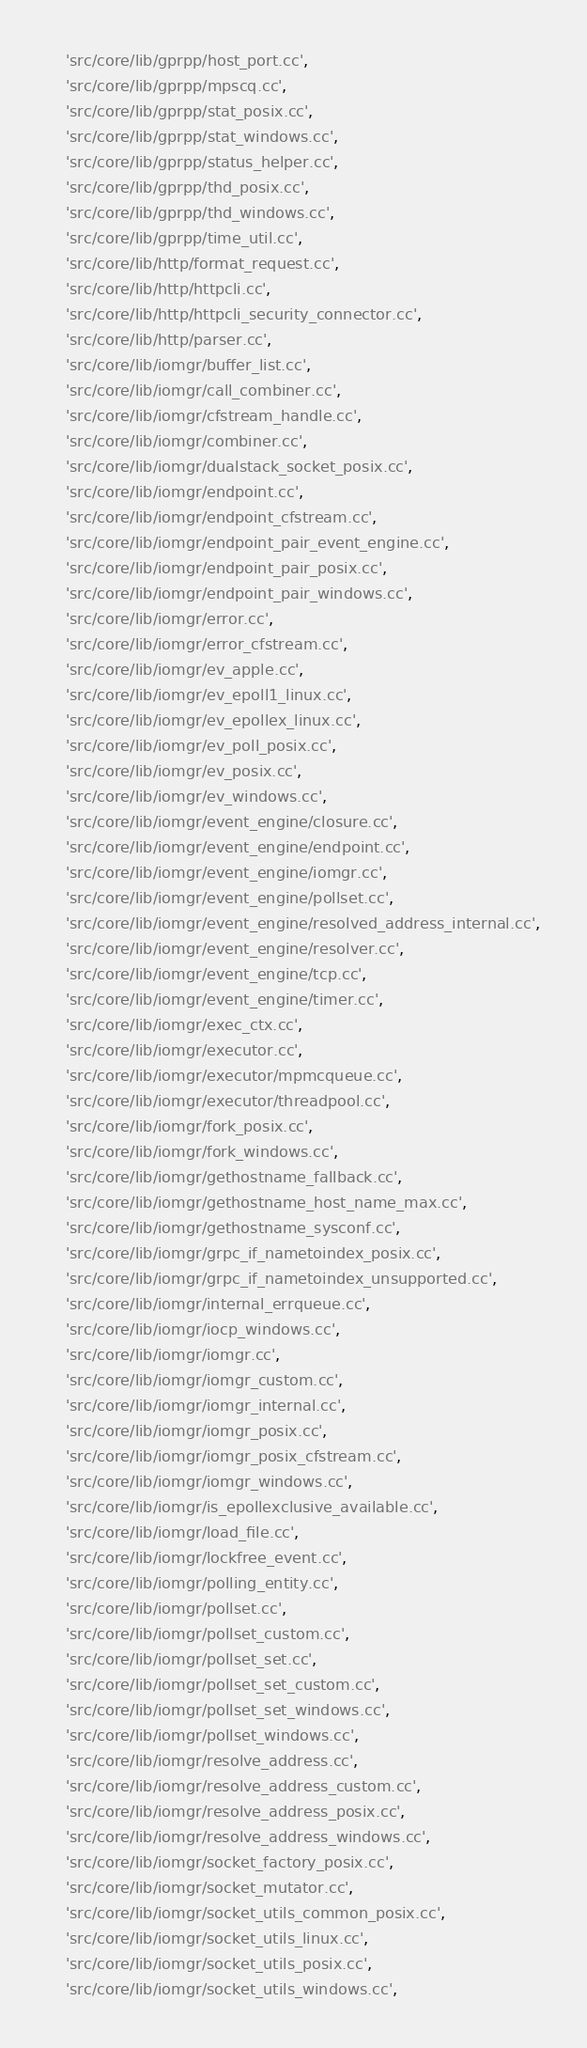Convert code to text. <code><loc_0><loc_0><loc_500><loc_500><_Python_>    'src/core/lib/gprpp/host_port.cc',
    'src/core/lib/gprpp/mpscq.cc',
    'src/core/lib/gprpp/stat_posix.cc',
    'src/core/lib/gprpp/stat_windows.cc',
    'src/core/lib/gprpp/status_helper.cc',
    'src/core/lib/gprpp/thd_posix.cc',
    'src/core/lib/gprpp/thd_windows.cc',
    'src/core/lib/gprpp/time_util.cc',
    'src/core/lib/http/format_request.cc',
    'src/core/lib/http/httpcli.cc',
    'src/core/lib/http/httpcli_security_connector.cc',
    'src/core/lib/http/parser.cc',
    'src/core/lib/iomgr/buffer_list.cc',
    'src/core/lib/iomgr/call_combiner.cc',
    'src/core/lib/iomgr/cfstream_handle.cc',
    'src/core/lib/iomgr/combiner.cc',
    'src/core/lib/iomgr/dualstack_socket_posix.cc',
    'src/core/lib/iomgr/endpoint.cc',
    'src/core/lib/iomgr/endpoint_cfstream.cc',
    'src/core/lib/iomgr/endpoint_pair_event_engine.cc',
    'src/core/lib/iomgr/endpoint_pair_posix.cc',
    'src/core/lib/iomgr/endpoint_pair_windows.cc',
    'src/core/lib/iomgr/error.cc',
    'src/core/lib/iomgr/error_cfstream.cc',
    'src/core/lib/iomgr/ev_apple.cc',
    'src/core/lib/iomgr/ev_epoll1_linux.cc',
    'src/core/lib/iomgr/ev_epollex_linux.cc',
    'src/core/lib/iomgr/ev_poll_posix.cc',
    'src/core/lib/iomgr/ev_posix.cc',
    'src/core/lib/iomgr/ev_windows.cc',
    'src/core/lib/iomgr/event_engine/closure.cc',
    'src/core/lib/iomgr/event_engine/endpoint.cc',
    'src/core/lib/iomgr/event_engine/iomgr.cc',
    'src/core/lib/iomgr/event_engine/pollset.cc',
    'src/core/lib/iomgr/event_engine/resolved_address_internal.cc',
    'src/core/lib/iomgr/event_engine/resolver.cc',
    'src/core/lib/iomgr/event_engine/tcp.cc',
    'src/core/lib/iomgr/event_engine/timer.cc',
    'src/core/lib/iomgr/exec_ctx.cc',
    'src/core/lib/iomgr/executor.cc',
    'src/core/lib/iomgr/executor/mpmcqueue.cc',
    'src/core/lib/iomgr/executor/threadpool.cc',
    'src/core/lib/iomgr/fork_posix.cc',
    'src/core/lib/iomgr/fork_windows.cc',
    'src/core/lib/iomgr/gethostname_fallback.cc',
    'src/core/lib/iomgr/gethostname_host_name_max.cc',
    'src/core/lib/iomgr/gethostname_sysconf.cc',
    'src/core/lib/iomgr/grpc_if_nametoindex_posix.cc',
    'src/core/lib/iomgr/grpc_if_nametoindex_unsupported.cc',
    'src/core/lib/iomgr/internal_errqueue.cc',
    'src/core/lib/iomgr/iocp_windows.cc',
    'src/core/lib/iomgr/iomgr.cc',
    'src/core/lib/iomgr/iomgr_custom.cc',
    'src/core/lib/iomgr/iomgr_internal.cc',
    'src/core/lib/iomgr/iomgr_posix.cc',
    'src/core/lib/iomgr/iomgr_posix_cfstream.cc',
    'src/core/lib/iomgr/iomgr_windows.cc',
    'src/core/lib/iomgr/is_epollexclusive_available.cc',
    'src/core/lib/iomgr/load_file.cc',
    'src/core/lib/iomgr/lockfree_event.cc',
    'src/core/lib/iomgr/polling_entity.cc',
    'src/core/lib/iomgr/pollset.cc',
    'src/core/lib/iomgr/pollset_custom.cc',
    'src/core/lib/iomgr/pollset_set.cc',
    'src/core/lib/iomgr/pollset_set_custom.cc',
    'src/core/lib/iomgr/pollset_set_windows.cc',
    'src/core/lib/iomgr/pollset_windows.cc',
    'src/core/lib/iomgr/resolve_address.cc',
    'src/core/lib/iomgr/resolve_address_custom.cc',
    'src/core/lib/iomgr/resolve_address_posix.cc',
    'src/core/lib/iomgr/resolve_address_windows.cc',
    'src/core/lib/iomgr/socket_factory_posix.cc',
    'src/core/lib/iomgr/socket_mutator.cc',
    'src/core/lib/iomgr/socket_utils_common_posix.cc',
    'src/core/lib/iomgr/socket_utils_linux.cc',
    'src/core/lib/iomgr/socket_utils_posix.cc',
    'src/core/lib/iomgr/socket_utils_windows.cc',</code> 